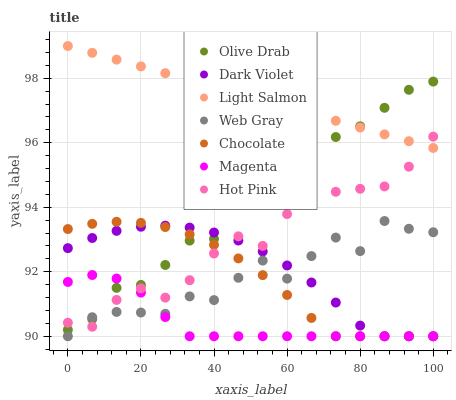Does Magenta have the minimum area under the curve?
Answer yes or no. Yes. Does Light Salmon have the maximum area under the curve?
Answer yes or no. Yes. Does Web Gray have the minimum area under the curve?
Answer yes or no. No. Does Web Gray have the maximum area under the curve?
Answer yes or no. No. Is Light Salmon the smoothest?
Answer yes or no. Yes. Is Web Gray the roughest?
Answer yes or no. Yes. Is Hot Pink the smoothest?
Answer yes or no. No. Is Hot Pink the roughest?
Answer yes or no. No. Does Web Gray have the lowest value?
Answer yes or no. Yes. Does Hot Pink have the lowest value?
Answer yes or no. No. Does Light Salmon have the highest value?
Answer yes or no. Yes. Does Web Gray have the highest value?
Answer yes or no. No. Is Magenta less than Light Salmon?
Answer yes or no. Yes. Is Light Salmon greater than Web Gray?
Answer yes or no. Yes. Does Magenta intersect Web Gray?
Answer yes or no. Yes. Is Magenta less than Web Gray?
Answer yes or no. No. Is Magenta greater than Web Gray?
Answer yes or no. No. Does Magenta intersect Light Salmon?
Answer yes or no. No. 